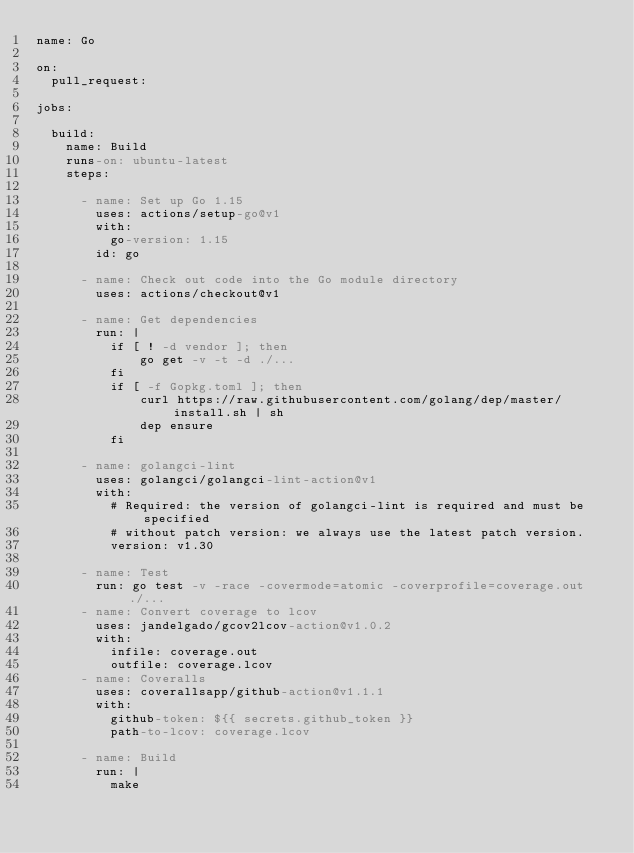Convert code to text. <code><loc_0><loc_0><loc_500><loc_500><_YAML_>name: Go

on:
  pull_request:

jobs:

  build:
    name: Build
    runs-on: ubuntu-latest
    steps:

      - name: Set up Go 1.15
        uses: actions/setup-go@v1
        with:
          go-version: 1.15
        id: go

      - name: Check out code into the Go module directory
        uses: actions/checkout@v1

      - name: Get dependencies
        run: |
          if [ ! -d vendor ]; then
              go get -v -t -d ./...
          fi
          if [ -f Gopkg.toml ]; then
              curl https://raw.githubusercontent.com/golang/dep/master/install.sh | sh
              dep ensure
          fi

      - name: golangci-lint
        uses: golangci/golangci-lint-action@v1
        with:
          # Required: the version of golangci-lint is required and must be specified
          # without patch version: we always use the latest patch version.
          version: v1.30

      - name: Test
        run: go test -v -race -covermode=atomic -coverprofile=coverage.out ./...
      - name: Convert coverage to lcov
        uses: jandelgado/gcov2lcov-action@v1.0.2
        with:
          infile: coverage.out
          outfile: coverage.lcov
      - name: Coveralls
        uses: coverallsapp/github-action@v1.1.1
        with:
          github-token: ${{ secrets.github_token }}
          path-to-lcov: coverage.lcov

      - name: Build
        run: |
          make
</code> 